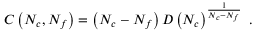<formula> <loc_0><loc_0><loc_500><loc_500>C \left ( N _ { c } , N _ { f } \right ) = \left ( N _ { c } - N _ { f } \right ) D \left ( N _ { c } \right ) ^ { \frac { 1 } { N _ { c } - N _ { f } } } \ .</formula> 